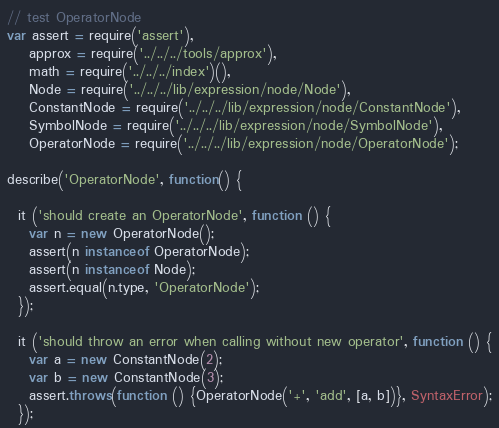Convert code to text. <code><loc_0><loc_0><loc_500><loc_500><_JavaScript_>// test OperatorNode
var assert = require('assert'),
    approx = require('../../../tools/approx'),
    math = require('../../../index')(),
    Node = require('../../../lib/expression/node/Node'),
    ConstantNode = require('../../../lib/expression/node/ConstantNode'),
    SymbolNode = require('../../../lib/expression/node/SymbolNode'),
    OperatorNode = require('../../../lib/expression/node/OperatorNode');

describe('OperatorNode', function() {

  it ('should create an OperatorNode', function () {
    var n = new OperatorNode();
    assert(n instanceof OperatorNode);
    assert(n instanceof Node);
    assert.equal(n.type, 'OperatorNode');
  });

  it ('should throw an error when calling without new operator', function () {
    var a = new ConstantNode(2);
    var b = new ConstantNode(3);
    assert.throws(function () {OperatorNode('+', 'add', [a, b])}, SyntaxError);
  });
</code> 